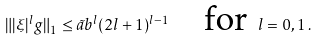Convert formula to latex. <formula><loc_0><loc_0><loc_500><loc_500>\| | \xi | ^ { l } g \| _ { 1 } \leq \tilde { a } b ^ { l } ( 2 l + 1 ) ^ { l - 1 } \quad \text {for } l = 0 , 1 \, .</formula> 